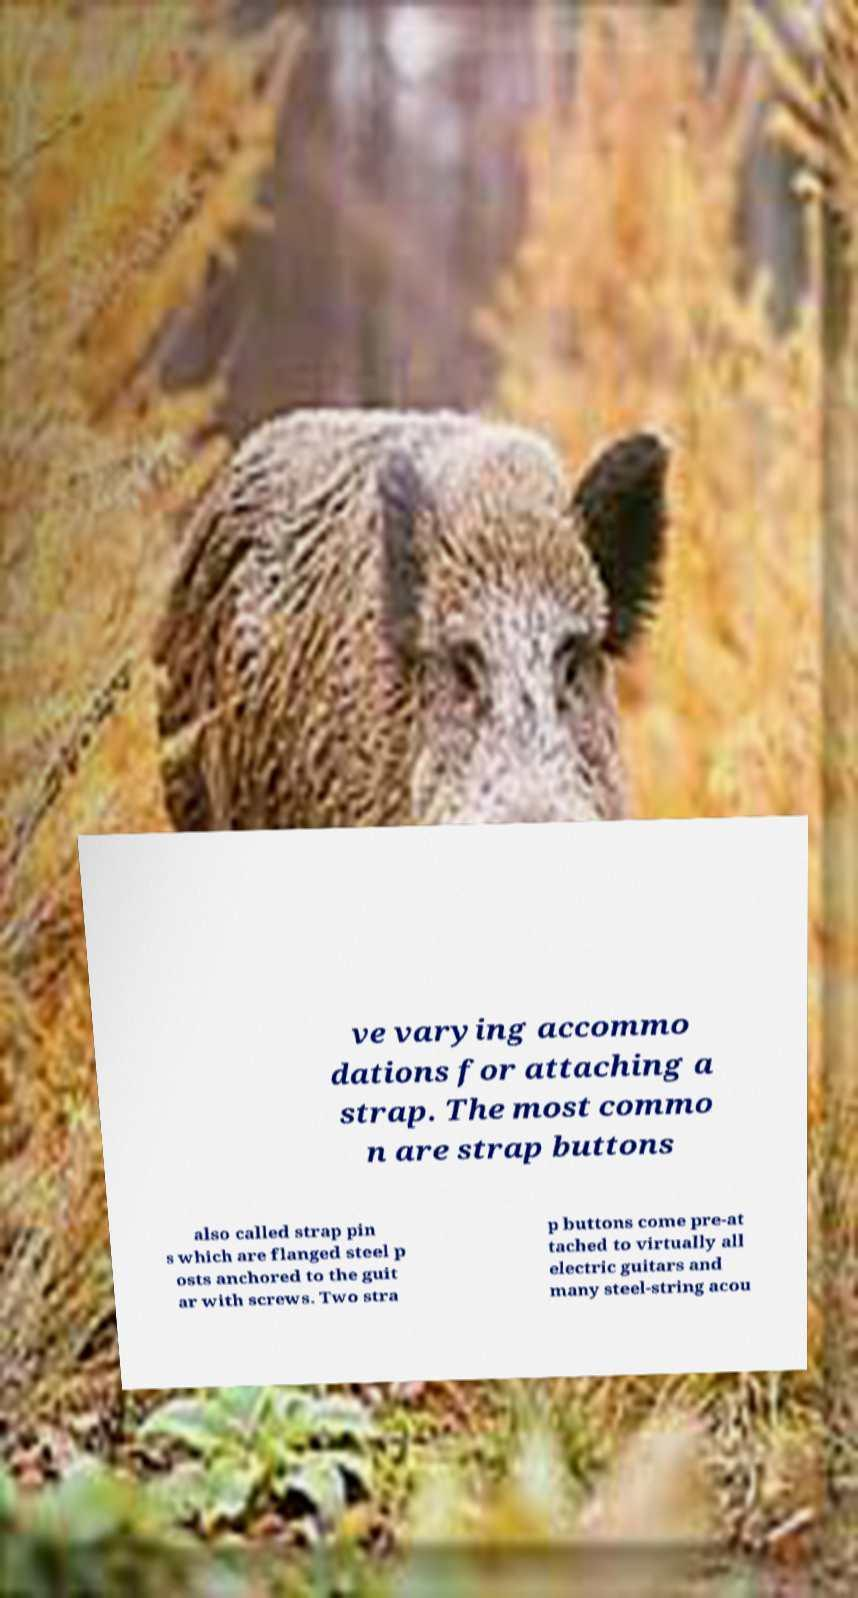Can you read and provide the text displayed in the image?This photo seems to have some interesting text. Can you extract and type it out for me? ve varying accommo dations for attaching a strap. The most commo n are strap buttons also called strap pin s which are flanged steel p osts anchored to the guit ar with screws. Two stra p buttons come pre-at tached to virtually all electric guitars and many steel-string acou 